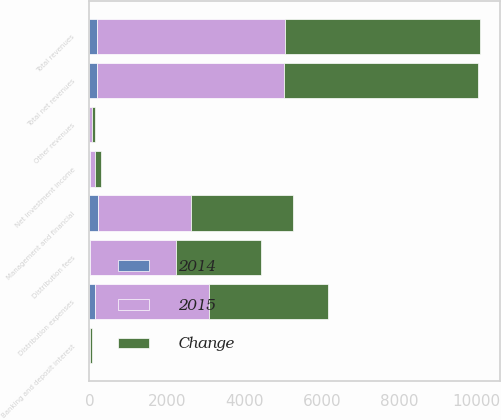Convert chart to OTSL. <chart><loc_0><loc_0><loc_500><loc_500><stacked_bar_chart><ecel><fcel>Management and financial<fcel>Distribution fees<fcel>Net investment income<fcel>Other revenues<fcel>Total revenues<fcel>Banking and deposit interest<fcel>Total net revenues<fcel>Distribution expenses<nl><fcel>Change<fcel>2629<fcel>2195<fcel>146<fcel>73<fcel>5043<fcel>30<fcel>5013<fcel>3081<nl><fcel>2015<fcel>2413<fcel>2213<fcel>136<fcel>72<fcel>4834<fcel>28<fcel>4806<fcel>2943<nl><fcel>2014<fcel>216<fcel>18<fcel>10<fcel>1<fcel>209<fcel>2<fcel>207<fcel>138<nl></chart> 